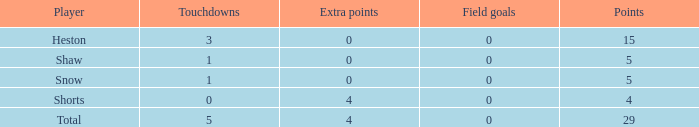What is the cumulative amount of field goals for a participant with under 3 touchdowns, 4 points, and less than 4 extra points? 0.0. 